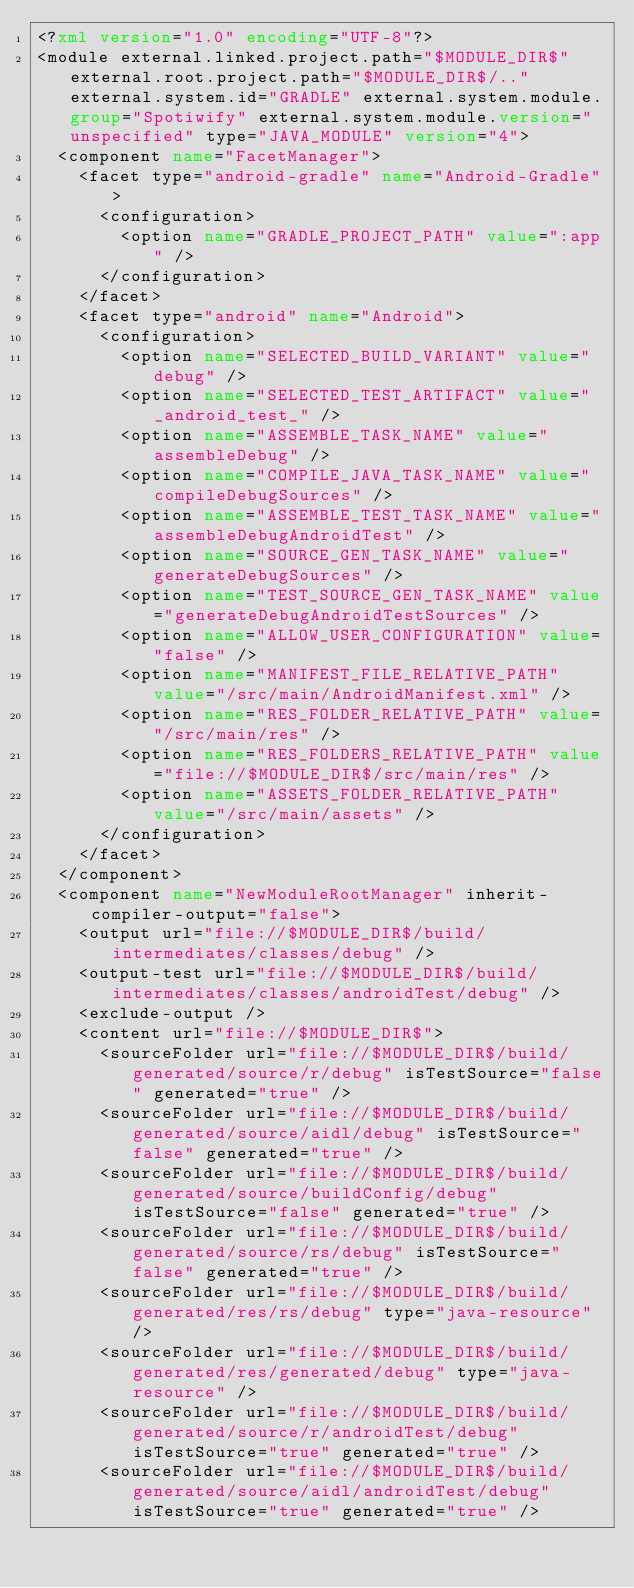<code> <loc_0><loc_0><loc_500><loc_500><_XML_><?xml version="1.0" encoding="UTF-8"?>
<module external.linked.project.path="$MODULE_DIR$" external.root.project.path="$MODULE_DIR$/.." external.system.id="GRADLE" external.system.module.group="Spotiwify" external.system.module.version="unspecified" type="JAVA_MODULE" version="4">
  <component name="FacetManager">
    <facet type="android-gradle" name="Android-Gradle">
      <configuration>
        <option name="GRADLE_PROJECT_PATH" value=":app" />
      </configuration>
    </facet>
    <facet type="android" name="Android">
      <configuration>
        <option name="SELECTED_BUILD_VARIANT" value="debug" />
        <option name="SELECTED_TEST_ARTIFACT" value="_android_test_" />
        <option name="ASSEMBLE_TASK_NAME" value="assembleDebug" />
        <option name="COMPILE_JAVA_TASK_NAME" value="compileDebugSources" />
        <option name="ASSEMBLE_TEST_TASK_NAME" value="assembleDebugAndroidTest" />
        <option name="SOURCE_GEN_TASK_NAME" value="generateDebugSources" />
        <option name="TEST_SOURCE_GEN_TASK_NAME" value="generateDebugAndroidTestSources" />
        <option name="ALLOW_USER_CONFIGURATION" value="false" />
        <option name="MANIFEST_FILE_RELATIVE_PATH" value="/src/main/AndroidManifest.xml" />
        <option name="RES_FOLDER_RELATIVE_PATH" value="/src/main/res" />
        <option name="RES_FOLDERS_RELATIVE_PATH" value="file://$MODULE_DIR$/src/main/res" />
        <option name="ASSETS_FOLDER_RELATIVE_PATH" value="/src/main/assets" />
      </configuration>
    </facet>
  </component>
  <component name="NewModuleRootManager" inherit-compiler-output="false">
    <output url="file://$MODULE_DIR$/build/intermediates/classes/debug" />
    <output-test url="file://$MODULE_DIR$/build/intermediates/classes/androidTest/debug" />
    <exclude-output />
    <content url="file://$MODULE_DIR$">
      <sourceFolder url="file://$MODULE_DIR$/build/generated/source/r/debug" isTestSource="false" generated="true" />
      <sourceFolder url="file://$MODULE_DIR$/build/generated/source/aidl/debug" isTestSource="false" generated="true" />
      <sourceFolder url="file://$MODULE_DIR$/build/generated/source/buildConfig/debug" isTestSource="false" generated="true" />
      <sourceFolder url="file://$MODULE_DIR$/build/generated/source/rs/debug" isTestSource="false" generated="true" />
      <sourceFolder url="file://$MODULE_DIR$/build/generated/res/rs/debug" type="java-resource" />
      <sourceFolder url="file://$MODULE_DIR$/build/generated/res/generated/debug" type="java-resource" />
      <sourceFolder url="file://$MODULE_DIR$/build/generated/source/r/androidTest/debug" isTestSource="true" generated="true" />
      <sourceFolder url="file://$MODULE_DIR$/build/generated/source/aidl/androidTest/debug" isTestSource="true" generated="true" /></code> 